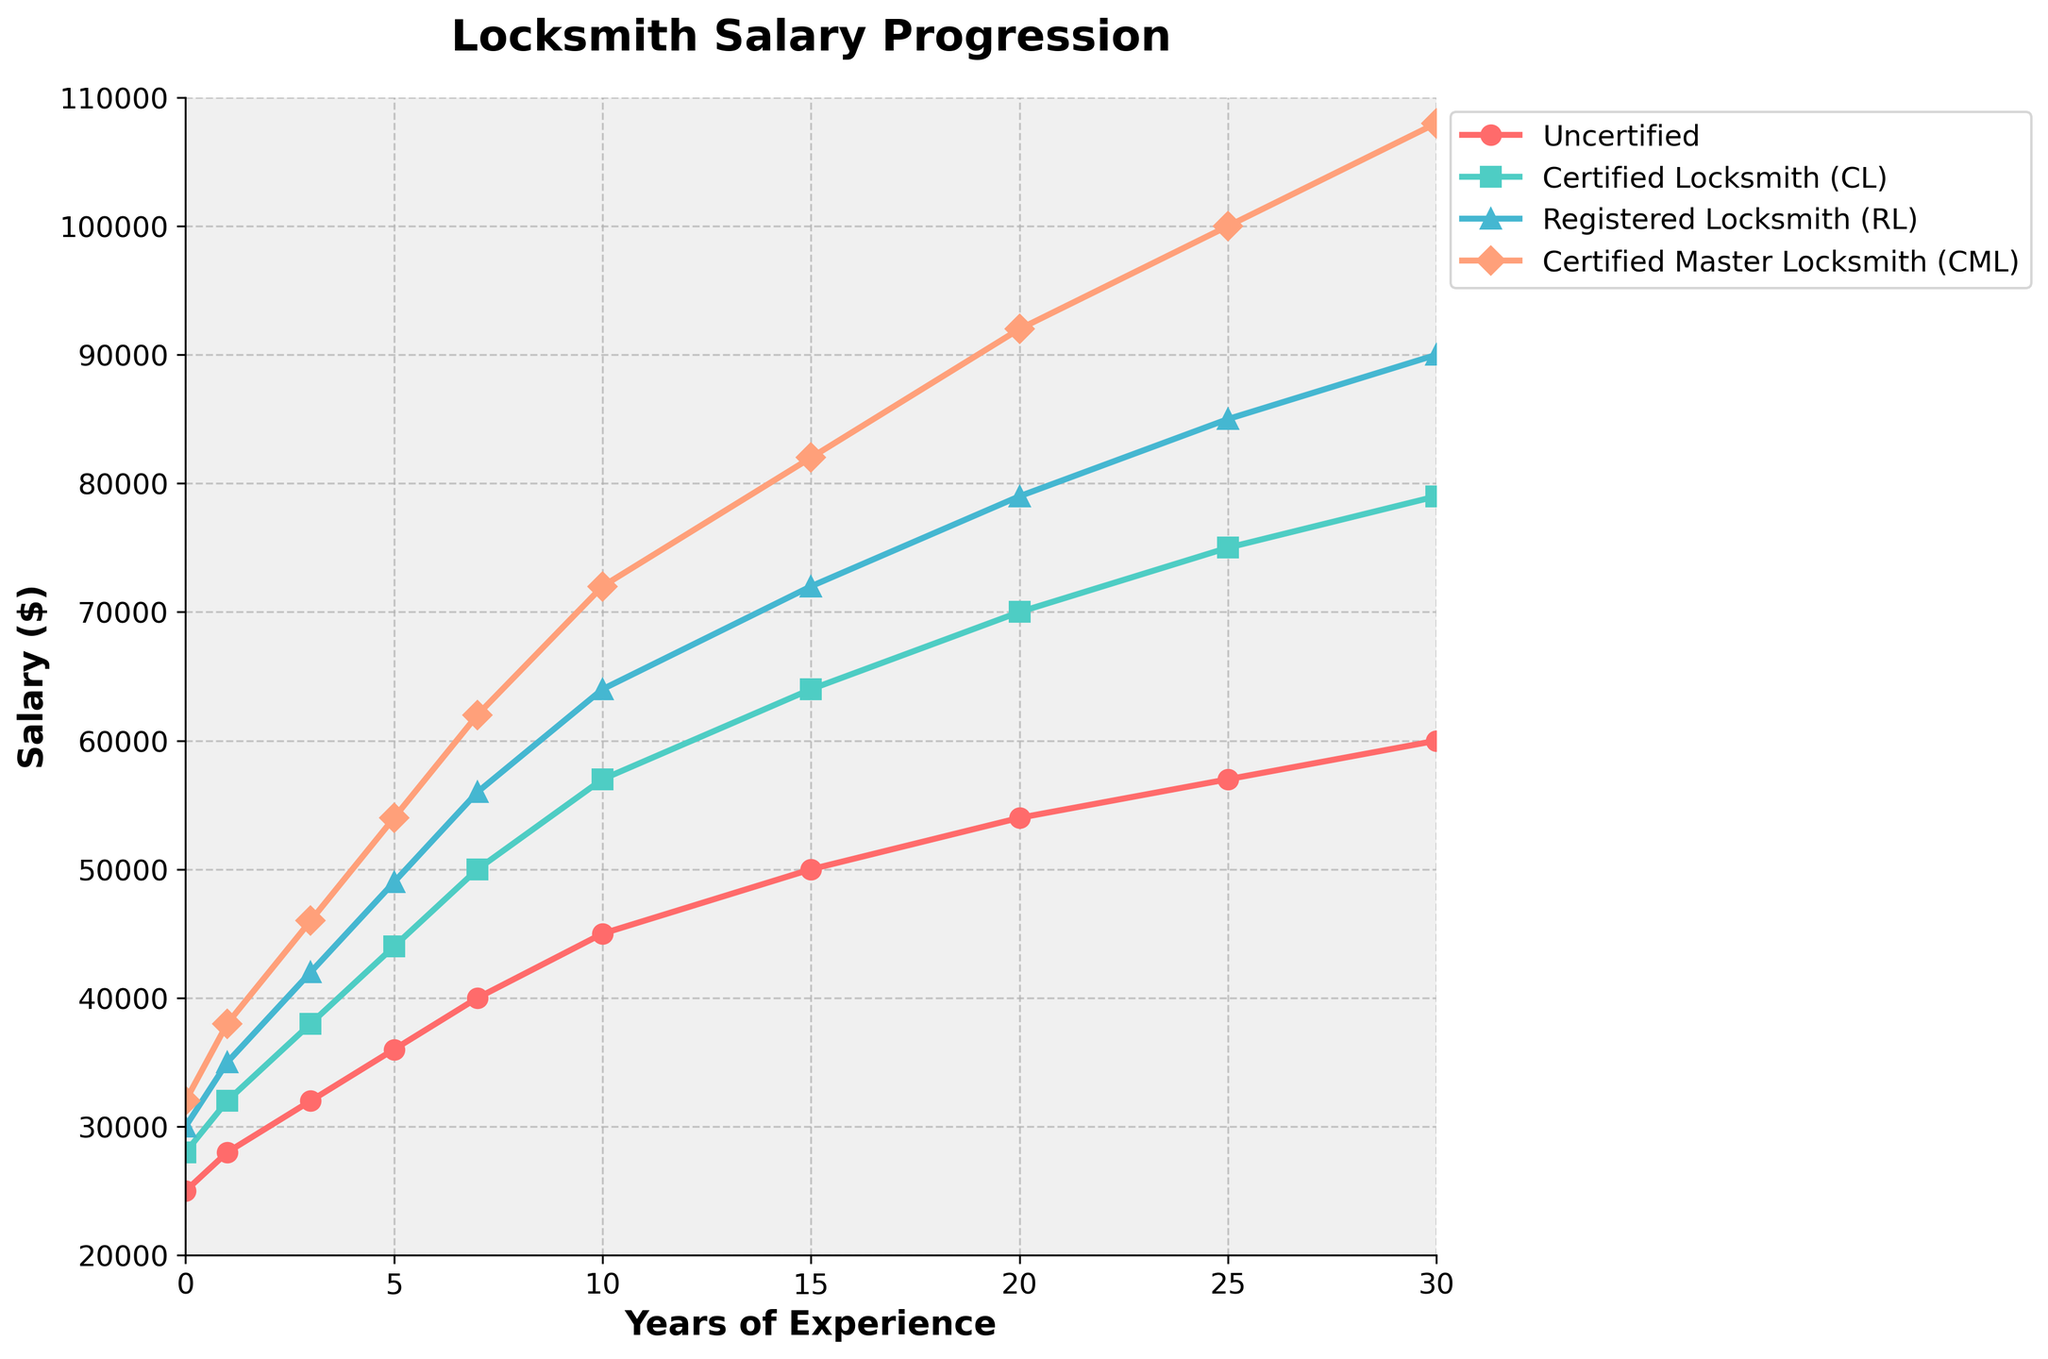What is the salary difference between an Uncertified locksmith and a Certified Master Locksmith (CML) with 10 years of experience? To find the salary difference, locate the salaries for both categories at 10 years of experience. The salary for an Uncertified locksmith is $45,000, and for a Certified Master Locksmith (CML), it is $72,000. Subtract the Uncertified salary from the CML salary: $72,000 - $45,000 = $27,000.
Answer: $27,000 Which certification level shows the highest salary increase from 0 to 10 years of experience? Calculate the difference in salary at 0 and 10 years for each certification level. Uncertified: $45,000 - $25,000 = $20,000. CL: $57,000 - $28,000 = $29,000. RL: $64,000 - $30,000 = $34,000. CML: $72,000 - $32,000 = $40,000. The highest increase is for CML with $40,000.
Answer: CML At 15 years of experience, what is the salary of a Certified Locksmith (CL) and how far is it below that of a Registered Locksmith (RL)? Find the salaries at 15 years for both CL and RL. CL: $64,000, RL: $72,000. Difference: $72,000 - $64,000 = $8,000.
Answer: $8,000 By how much does the average salary increase per year for a Registered Locksmith (RL) from 0 to 20 years of experience? Calculate the total increase for RL over 20 years and then divide by 20. Initial salary: $30,000, after 20 years: $79,000. Difference: $79,000 - $30,000 = $49,000. Average yearly increase: $49,000 / 20 = $2,450.
Answer: $2,450 What is the color representation of the plot line corresponding to Uncertified locksmiths? In the figure, the Uncertified locksmiths' salary progression is represented with the color red.
Answer: Red Which certification level has the highest salary at 30 years of experience, and what is that salary? Identify the salary values at 30 years for each certification. The highest is CML with a salary of $108,000.
Answer: CML, $108,000 Is there any certification level where the salary doubles from 0 to 25 years of experience? If so, which one(s)? Calculate if the salary at 25 years is at least double the initial salary for each certification. Uncertified: $57,000 is more than double $25,000. CL: $75,000 is more than double $28,000. RL: $85,000 is more than double $30,000. CML: $100,000 is more than double $32,000. Hence, all levels double.
Answer: All Levels Comparing the salary at 20 years of experience, which certification levels show a salary higher than $75,000? Check the salaries at 20 years of experience. CL: $70,000, RL: $79,000, CML: $92,000. Both RL and CML have salaries higher than $75,000.
Answer: RL and CML 